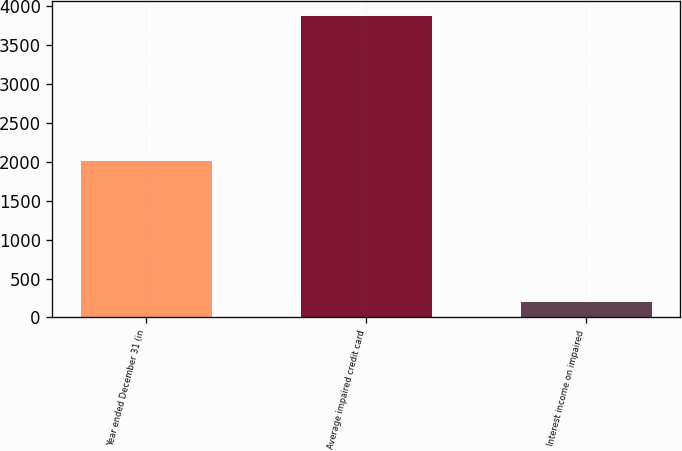Convert chart to OTSL. <chart><loc_0><loc_0><loc_500><loc_500><bar_chart><fcel>Year ended December 31 (in<fcel>Average impaired credit card<fcel>Interest income on impaired<nl><fcel>2013<fcel>3882<fcel>198<nl></chart> 